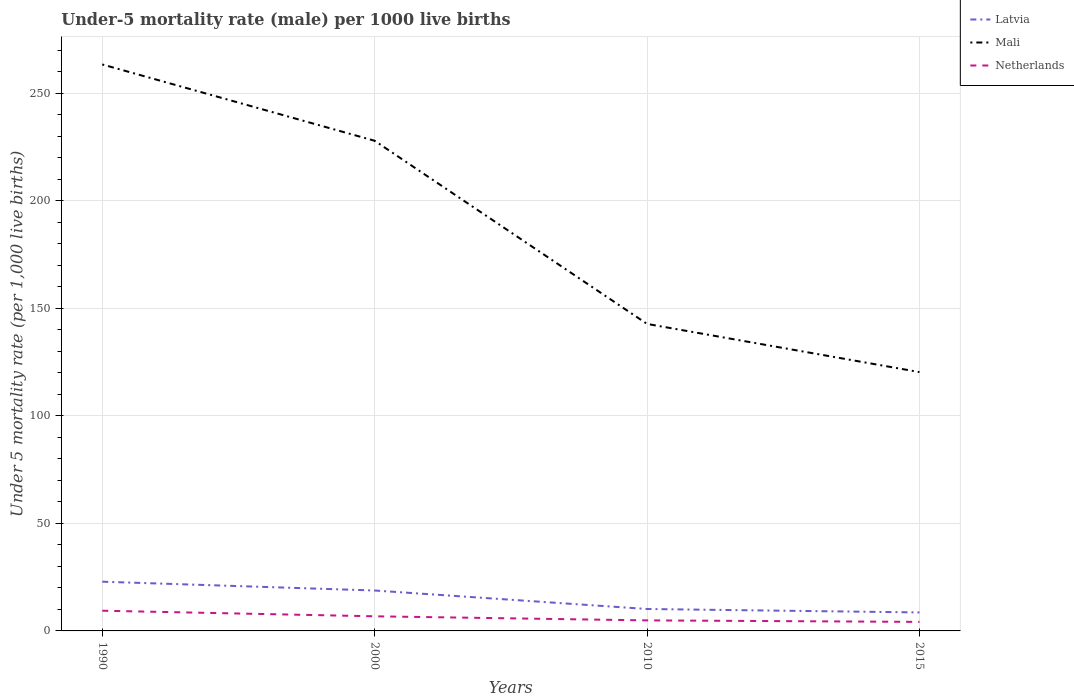How many different coloured lines are there?
Your answer should be very brief. 3. Does the line corresponding to Mali intersect with the line corresponding to Netherlands?
Make the answer very short. No. In which year was the under-five mortality rate in Mali maximum?
Provide a succinct answer. 2015. What is the total under-five mortality rate in Latvia in the graph?
Offer a very short reply. 10.2. What is the difference between the highest and the second highest under-five mortality rate in Mali?
Make the answer very short. 143.1. Is the under-five mortality rate in Latvia strictly greater than the under-five mortality rate in Mali over the years?
Keep it short and to the point. Yes. Are the values on the major ticks of Y-axis written in scientific E-notation?
Your answer should be compact. No. Does the graph contain any zero values?
Your answer should be compact. No. Where does the legend appear in the graph?
Ensure brevity in your answer.  Top right. How are the legend labels stacked?
Your answer should be very brief. Vertical. What is the title of the graph?
Provide a short and direct response. Under-5 mortality rate (male) per 1000 live births. What is the label or title of the X-axis?
Your answer should be very brief. Years. What is the label or title of the Y-axis?
Ensure brevity in your answer.  Under 5 mortality rate (per 1,0 live births). What is the Under 5 mortality rate (per 1,000 live births) of Latvia in 1990?
Offer a very short reply. 22.9. What is the Under 5 mortality rate (per 1,000 live births) of Mali in 1990?
Give a very brief answer. 263.5. What is the Under 5 mortality rate (per 1,000 live births) in Mali in 2000?
Your answer should be very brief. 228. What is the Under 5 mortality rate (per 1,000 live births) in Netherlands in 2000?
Give a very brief answer. 6.8. What is the Under 5 mortality rate (per 1,000 live births) of Mali in 2010?
Provide a succinct answer. 142.8. What is the Under 5 mortality rate (per 1,000 live births) of Latvia in 2015?
Keep it short and to the point. 8.6. What is the Under 5 mortality rate (per 1,000 live births) of Mali in 2015?
Your response must be concise. 120.4. What is the Under 5 mortality rate (per 1,000 live births) in Netherlands in 2015?
Offer a very short reply. 4.2. Across all years, what is the maximum Under 5 mortality rate (per 1,000 live births) in Latvia?
Make the answer very short. 22.9. Across all years, what is the maximum Under 5 mortality rate (per 1,000 live births) of Mali?
Your response must be concise. 263.5. Across all years, what is the minimum Under 5 mortality rate (per 1,000 live births) of Latvia?
Offer a terse response. 8.6. Across all years, what is the minimum Under 5 mortality rate (per 1,000 live births) in Mali?
Give a very brief answer. 120.4. What is the total Under 5 mortality rate (per 1,000 live births) of Latvia in the graph?
Offer a terse response. 60.5. What is the total Under 5 mortality rate (per 1,000 live births) of Mali in the graph?
Your response must be concise. 754.7. What is the total Under 5 mortality rate (per 1,000 live births) in Netherlands in the graph?
Offer a very short reply. 25.3. What is the difference between the Under 5 mortality rate (per 1,000 live births) in Mali in 1990 and that in 2000?
Provide a short and direct response. 35.5. What is the difference between the Under 5 mortality rate (per 1,000 live births) in Netherlands in 1990 and that in 2000?
Keep it short and to the point. 2.6. What is the difference between the Under 5 mortality rate (per 1,000 live births) in Mali in 1990 and that in 2010?
Your response must be concise. 120.7. What is the difference between the Under 5 mortality rate (per 1,000 live births) in Latvia in 1990 and that in 2015?
Provide a short and direct response. 14.3. What is the difference between the Under 5 mortality rate (per 1,000 live births) of Mali in 1990 and that in 2015?
Provide a succinct answer. 143.1. What is the difference between the Under 5 mortality rate (per 1,000 live births) of Netherlands in 1990 and that in 2015?
Offer a terse response. 5.2. What is the difference between the Under 5 mortality rate (per 1,000 live births) in Mali in 2000 and that in 2010?
Your answer should be compact. 85.2. What is the difference between the Under 5 mortality rate (per 1,000 live births) of Latvia in 2000 and that in 2015?
Provide a succinct answer. 10.2. What is the difference between the Under 5 mortality rate (per 1,000 live births) in Mali in 2000 and that in 2015?
Your answer should be very brief. 107.6. What is the difference between the Under 5 mortality rate (per 1,000 live births) in Netherlands in 2000 and that in 2015?
Provide a short and direct response. 2.6. What is the difference between the Under 5 mortality rate (per 1,000 live births) in Latvia in 2010 and that in 2015?
Offer a terse response. 1.6. What is the difference between the Under 5 mortality rate (per 1,000 live births) in Mali in 2010 and that in 2015?
Make the answer very short. 22.4. What is the difference between the Under 5 mortality rate (per 1,000 live births) in Latvia in 1990 and the Under 5 mortality rate (per 1,000 live births) in Mali in 2000?
Your answer should be very brief. -205.1. What is the difference between the Under 5 mortality rate (per 1,000 live births) of Mali in 1990 and the Under 5 mortality rate (per 1,000 live births) of Netherlands in 2000?
Your response must be concise. 256.7. What is the difference between the Under 5 mortality rate (per 1,000 live births) in Latvia in 1990 and the Under 5 mortality rate (per 1,000 live births) in Mali in 2010?
Your response must be concise. -119.9. What is the difference between the Under 5 mortality rate (per 1,000 live births) in Latvia in 1990 and the Under 5 mortality rate (per 1,000 live births) in Netherlands in 2010?
Your answer should be compact. 18. What is the difference between the Under 5 mortality rate (per 1,000 live births) in Mali in 1990 and the Under 5 mortality rate (per 1,000 live births) in Netherlands in 2010?
Keep it short and to the point. 258.6. What is the difference between the Under 5 mortality rate (per 1,000 live births) of Latvia in 1990 and the Under 5 mortality rate (per 1,000 live births) of Mali in 2015?
Ensure brevity in your answer.  -97.5. What is the difference between the Under 5 mortality rate (per 1,000 live births) in Latvia in 1990 and the Under 5 mortality rate (per 1,000 live births) in Netherlands in 2015?
Ensure brevity in your answer.  18.7. What is the difference between the Under 5 mortality rate (per 1,000 live births) of Mali in 1990 and the Under 5 mortality rate (per 1,000 live births) of Netherlands in 2015?
Your response must be concise. 259.3. What is the difference between the Under 5 mortality rate (per 1,000 live births) in Latvia in 2000 and the Under 5 mortality rate (per 1,000 live births) in Mali in 2010?
Make the answer very short. -124. What is the difference between the Under 5 mortality rate (per 1,000 live births) in Mali in 2000 and the Under 5 mortality rate (per 1,000 live births) in Netherlands in 2010?
Ensure brevity in your answer.  223.1. What is the difference between the Under 5 mortality rate (per 1,000 live births) of Latvia in 2000 and the Under 5 mortality rate (per 1,000 live births) of Mali in 2015?
Keep it short and to the point. -101.6. What is the difference between the Under 5 mortality rate (per 1,000 live births) of Latvia in 2000 and the Under 5 mortality rate (per 1,000 live births) of Netherlands in 2015?
Give a very brief answer. 14.6. What is the difference between the Under 5 mortality rate (per 1,000 live births) of Mali in 2000 and the Under 5 mortality rate (per 1,000 live births) of Netherlands in 2015?
Your answer should be very brief. 223.8. What is the difference between the Under 5 mortality rate (per 1,000 live births) of Latvia in 2010 and the Under 5 mortality rate (per 1,000 live births) of Mali in 2015?
Give a very brief answer. -110.2. What is the difference between the Under 5 mortality rate (per 1,000 live births) in Latvia in 2010 and the Under 5 mortality rate (per 1,000 live births) in Netherlands in 2015?
Provide a succinct answer. 6. What is the difference between the Under 5 mortality rate (per 1,000 live births) in Mali in 2010 and the Under 5 mortality rate (per 1,000 live births) in Netherlands in 2015?
Offer a very short reply. 138.6. What is the average Under 5 mortality rate (per 1,000 live births) of Latvia per year?
Provide a succinct answer. 15.12. What is the average Under 5 mortality rate (per 1,000 live births) in Mali per year?
Give a very brief answer. 188.68. What is the average Under 5 mortality rate (per 1,000 live births) in Netherlands per year?
Make the answer very short. 6.33. In the year 1990, what is the difference between the Under 5 mortality rate (per 1,000 live births) of Latvia and Under 5 mortality rate (per 1,000 live births) of Mali?
Your response must be concise. -240.6. In the year 1990, what is the difference between the Under 5 mortality rate (per 1,000 live births) of Latvia and Under 5 mortality rate (per 1,000 live births) of Netherlands?
Ensure brevity in your answer.  13.5. In the year 1990, what is the difference between the Under 5 mortality rate (per 1,000 live births) of Mali and Under 5 mortality rate (per 1,000 live births) of Netherlands?
Offer a terse response. 254.1. In the year 2000, what is the difference between the Under 5 mortality rate (per 1,000 live births) of Latvia and Under 5 mortality rate (per 1,000 live births) of Mali?
Keep it short and to the point. -209.2. In the year 2000, what is the difference between the Under 5 mortality rate (per 1,000 live births) of Mali and Under 5 mortality rate (per 1,000 live births) of Netherlands?
Make the answer very short. 221.2. In the year 2010, what is the difference between the Under 5 mortality rate (per 1,000 live births) of Latvia and Under 5 mortality rate (per 1,000 live births) of Mali?
Ensure brevity in your answer.  -132.6. In the year 2010, what is the difference between the Under 5 mortality rate (per 1,000 live births) of Mali and Under 5 mortality rate (per 1,000 live births) of Netherlands?
Your response must be concise. 137.9. In the year 2015, what is the difference between the Under 5 mortality rate (per 1,000 live births) in Latvia and Under 5 mortality rate (per 1,000 live births) in Mali?
Make the answer very short. -111.8. In the year 2015, what is the difference between the Under 5 mortality rate (per 1,000 live births) of Mali and Under 5 mortality rate (per 1,000 live births) of Netherlands?
Your answer should be very brief. 116.2. What is the ratio of the Under 5 mortality rate (per 1,000 live births) in Latvia in 1990 to that in 2000?
Offer a terse response. 1.22. What is the ratio of the Under 5 mortality rate (per 1,000 live births) in Mali in 1990 to that in 2000?
Keep it short and to the point. 1.16. What is the ratio of the Under 5 mortality rate (per 1,000 live births) in Netherlands in 1990 to that in 2000?
Keep it short and to the point. 1.38. What is the ratio of the Under 5 mortality rate (per 1,000 live births) in Latvia in 1990 to that in 2010?
Your answer should be very brief. 2.25. What is the ratio of the Under 5 mortality rate (per 1,000 live births) in Mali in 1990 to that in 2010?
Give a very brief answer. 1.85. What is the ratio of the Under 5 mortality rate (per 1,000 live births) of Netherlands in 1990 to that in 2010?
Make the answer very short. 1.92. What is the ratio of the Under 5 mortality rate (per 1,000 live births) of Latvia in 1990 to that in 2015?
Provide a succinct answer. 2.66. What is the ratio of the Under 5 mortality rate (per 1,000 live births) of Mali in 1990 to that in 2015?
Your response must be concise. 2.19. What is the ratio of the Under 5 mortality rate (per 1,000 live births) in Netherlands in 1990 to that in 2015?
Keep it short and to the point. 2.24. What is the ratio of the Under 5 mortality rate (per 1,000 live births) in Latvia in 2000 to that in 2010?
Keep it short and to the point. 1.84. What is the ratio of the Under 5 mortality rate (per 1,000 live births) of Mali in 2000 to that in 2010?
Keep it short and to the point. 1.6. What is the ratio of the Under 5 mortality rate (per 1,000 live births) in Netherlands in 2000 to that in 2010?
Your answer should be very brief. 1.39. What is the ratio of the Under 5 mortality rate (per 1,000 live births) of Latvia in 2000 to that in 2015?
Give a very brief answer. 2.19. What is the ratio of the Under 5 mortality rate (per 1,000 live births) of Mali in 2000 to that in 2015?
Your response must be concise. 1.89. What is the ratio of the Under 5 mortality rate (per 1,000 live births) in Netherlands in 2000 to that in 2015?
Provide a succinct answer. 1.62. What is the ratio of the Under 5 mortality rate (per 1,000 live births) in Latvia in 2010 to that in 2015?
Provide a short and direct response. 1.19. What is the ratio of the Under 5 mortality rate (per 1,000 live births) of Mali in 2010 to that in 2015?
Ensure brevity in your answer.  1.19. What is the difference between the highest and the second highest Under 5 mortality rate (per 1,000 live births) in Latvia?
Ensure brevity in your answer.  4.1. What is the difference between the highest and the second highest Under 5 mortality rate (per 1,000 live births) of Mali?
Provide a short and direct response. 35.5. What is the difference between the highest and the second highest Under 5 mortality rate (per 1,000 live births) of Netherlands?
Provide a short and direct response. 2.6. What is the difference between the highest and the lowest Under 5 mortality rate (per 1,000 live births) in Mali?
Make the answer very short. 143.1. What is the difference between the highest and the lowest Under 5 mortality rate (per 1,000 live births) of Netherlands?
Make the answer very short. 5.2. 